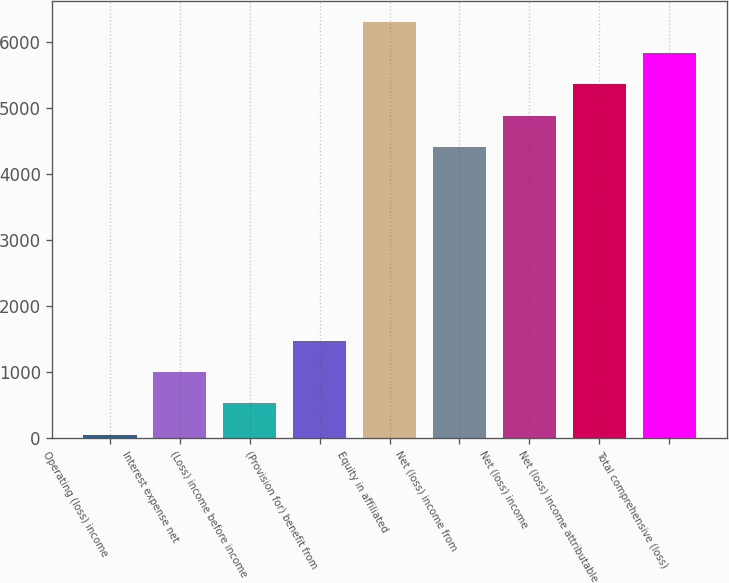Convert chart to OTSL. <chart><loc_0><loc_0><loc_500><loc_500><bar_chart><fcel>Operating (loss) income<fcel>Interest expense net<fcel>(Loss) income before income<fcel>(Provision for) benefit from<fcel>Equity in affiliated<fcel>Net (loss) income from<fcel>Net (loss) income<fcel>Net (loss) income attributable<fcel>Total comprehensive (loss)<nl><fcel>48<fcel>996.4<fcel>522.2<fcel>1470.6<fcel>6305.8<fcel>4409<fcel>4883.2<fcel>5357.4<fcel>5831.6<nl></chart> 